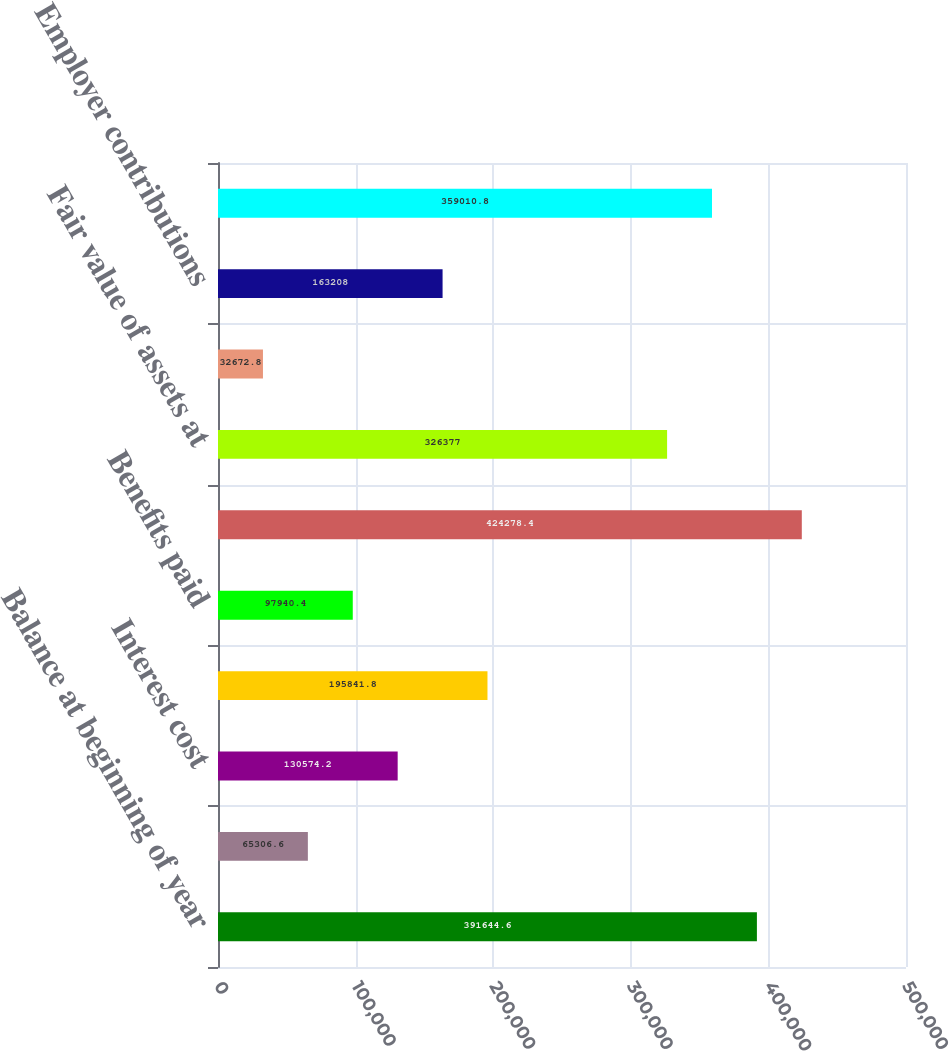Convert chart. <chart><loc_0><loc_0><loc_500><loc_500><bar_chart><fcel>Balance at beginning of year<fcel>Service cost<fcel>Interest cost<fcel>Actuarial loss<fcel>Benefits paid<fcel>Balance at end of year<fcel>Fair value of assets at<fcel>Actual return on plan assets<fcel>Employer contributions<fcel>Fair value of assets at end of<nl><fcel>391645<fcel>65306.6<fcel>130574<fcel>195842<fcel>97940.4<fcel>424278<fcel>326377<fcel>32672.8<fcel>163208<fcel>359011<nl></chart> 